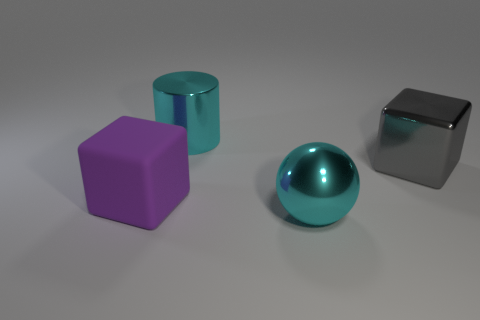Can you describe the texture on the surfaces of the objects? Certainly! The surfaces of the objects largely appear smooth and devoid of any pronounced texture. The lack of visible grain or roughness suggests that the objects may be designed to reflect light cleanly. The sphere, in particular, presents a mirror-like finish, indicating a high level of polish. 